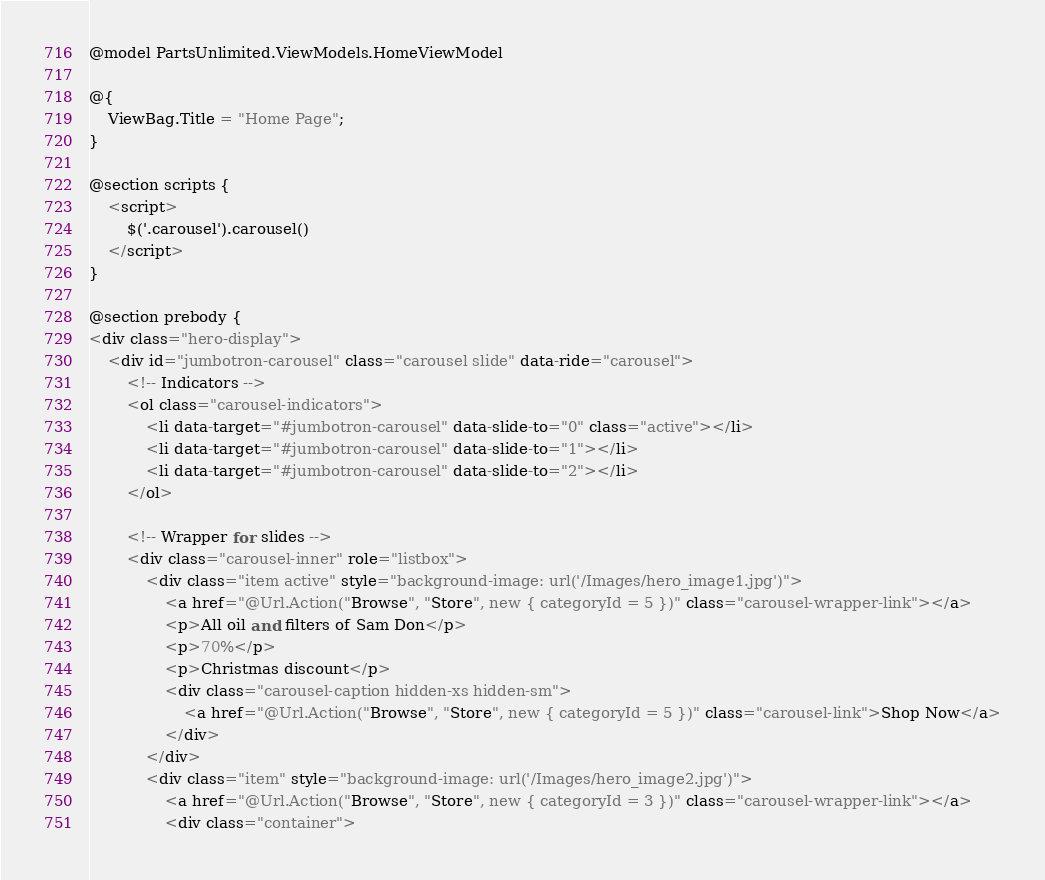Convert code to text. <code><loc_0><loc_0><loc_500><loc_500><_C#_>@model PartsUnlimited.ViewModels.HomeViewModel

@{
    ViewBag.Title = "Home Page";
}

@section scripts {
    <script>
        $('.carousel').carousel()
    </script>
}

@section prebody {
<div class="hero-display">
    <div id="jumbotron-carousel" class="carousel slide" data-ride="carousel">
        <!-- Indicators -->
        <ol class="carousel-indicators">
            <li data-target="#jumbotron-carousel" data-slide-to="0" class="active"></li>
            <li data-target="#jumbotron-carousel" data-slide-to="1"></li>
            <li data-target="#jumbotron-carousel" data-slide-to="2"></li>
        </ol>

        <!-- Wrapper for slides -->
        <div class="carousel-inner" role="listbox">
            <div class="item active" style="background-image: url('/Images/hero_image1.jpg')">
                <a href="@Url.Action("Browse", "Store", new { categoryId = 5 })" class="carousel-wrapper-link"></a>
                <p>All oil and filters of Sam Don</p>
                <p>70%</p>
                <p>Christmas discount</p>
                <div class="carousel-caption hidden-xs hidden-sm">
                    <a href="@Url.Action("Browse", "Store", new { categoryId = 5 })" class="carousel-link">Shop Now</a>
                </div>
            </div>
            <div class="item" style="background-image: url('/Images/hero_image2.jpg')">
                <a href="@Url.Action("Browse", "Store", new { categoryId = 3 })" class="carousel-wrapper-link"></a>
                <div class="container"></code> 